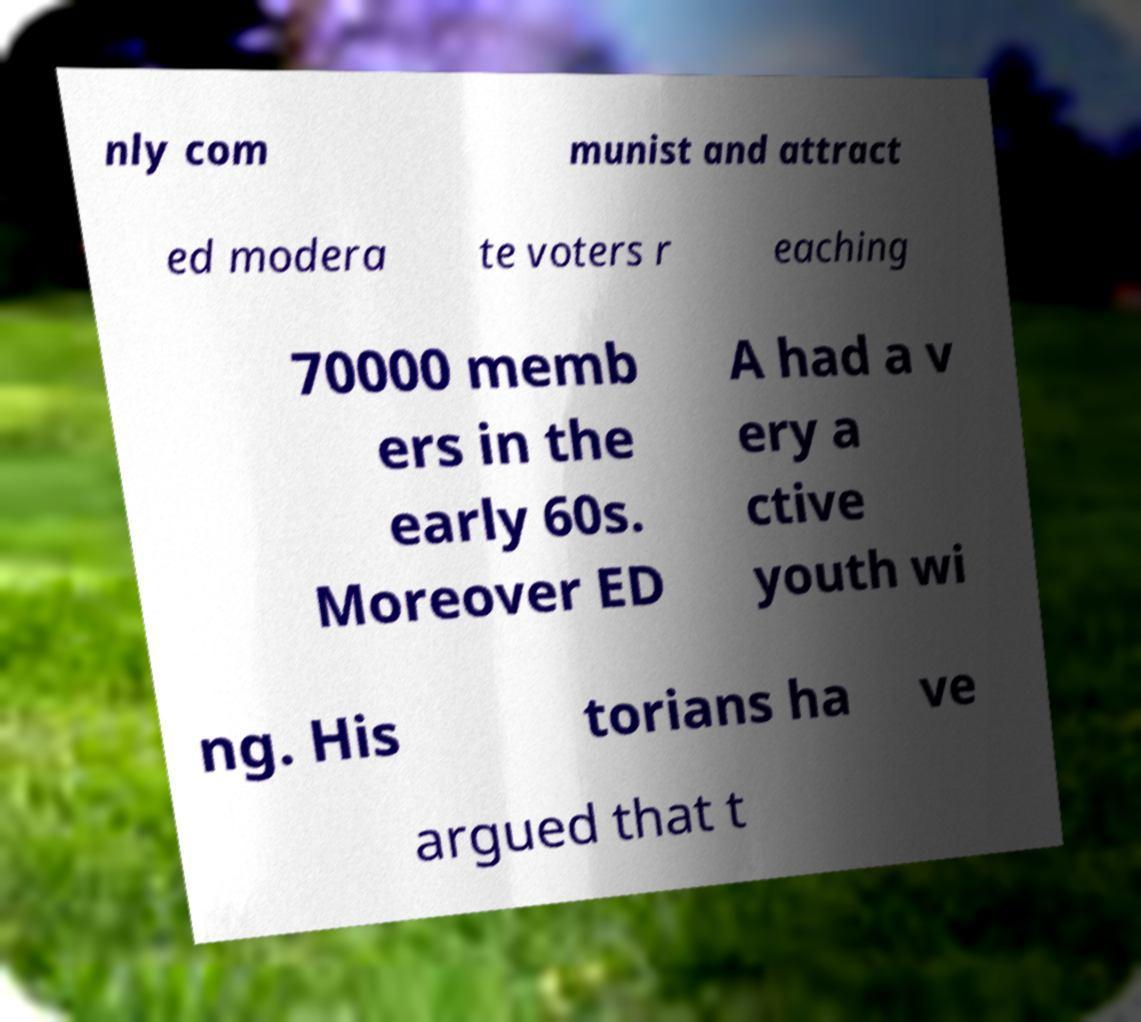What messages or text are displayed in this image? I need them in a readable, typed format. nly com munist and attract ed modera te voters r eaching 70000 memb ers in the early 60s. Moreover ED A had a v ery a ctive youth wi ng. His torians ha ve argued that t 